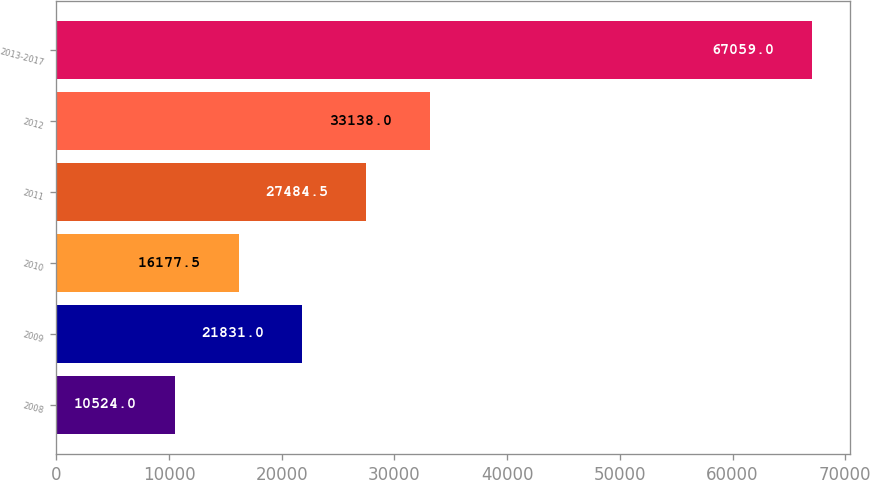Convert chart to OTSL. <chart><loc_0><loc_0><loc_500><loc_500><bar_chart><fcel>2008<fcel>2009<fcel>2010<fcel>2011<fcel>2012<fcel>2013-2017<nl><fcel>10524<fcel>21831<fcel>16177.5<fcel>27484.5<fcel>33138<fcel>67059<nl></chart> 